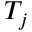<formula> <loc_0><loc_0><loc_500><loc_500>T _ { j }</formula> 